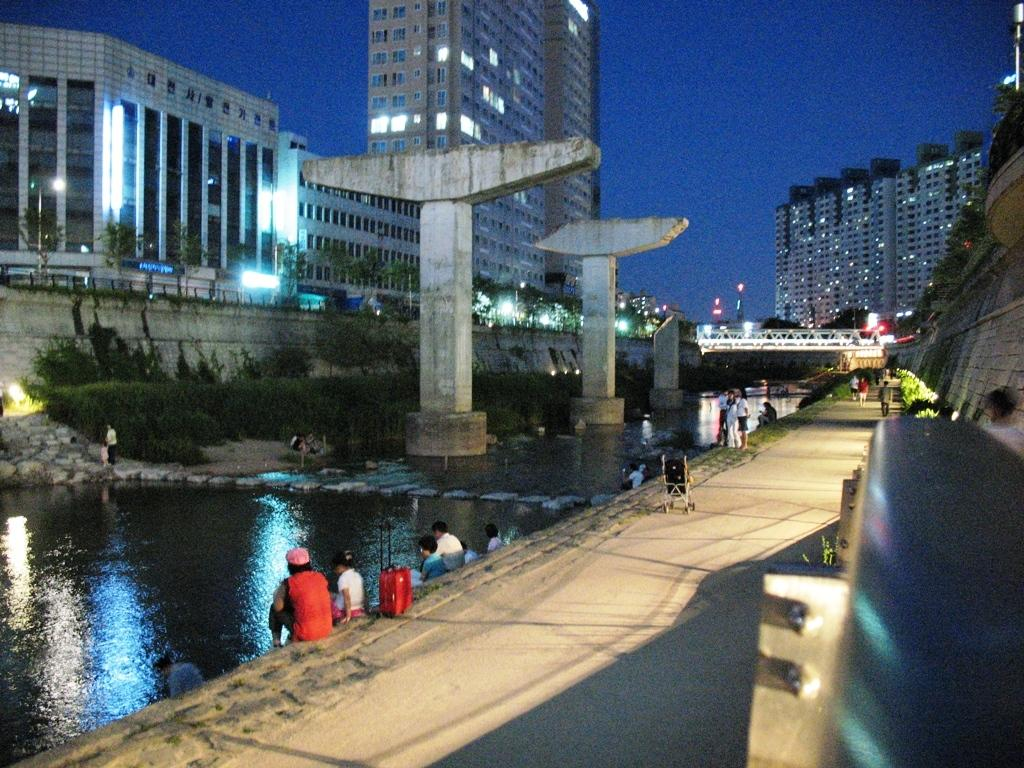Where are the people located in the image? The people are sitting in the left corner of the image. What is in front of the people? There is water visible in front of the people. What can be seen in the background of the image? There are buildings in the background of the image. What type of comb is being used by the people in the image? There is no comb visible in the image; the people are simply sitting in the left corner. 